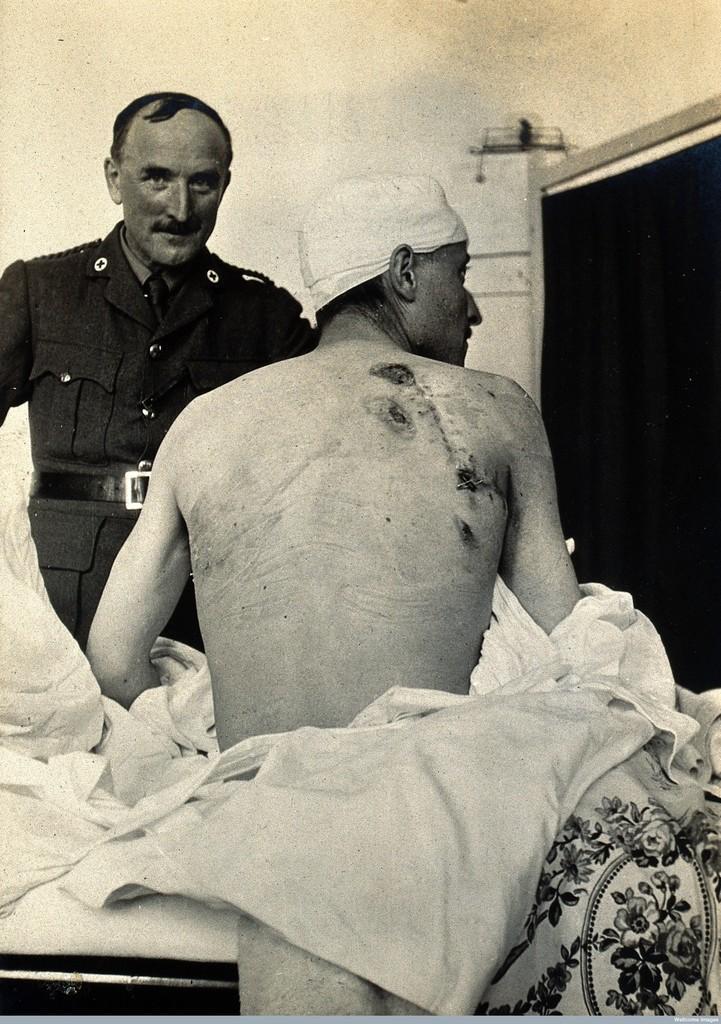Can you describe this image briefly? This is a black and white picture. In the middle of the picture, we see the man is sitting on the bed. Beside him, we see a white color bed sheet. In front of him, we see a man in the uniform is standing and he is looking at the camera. Behind him, we see a white wall. On the right side, we see a board or a door in black color. 